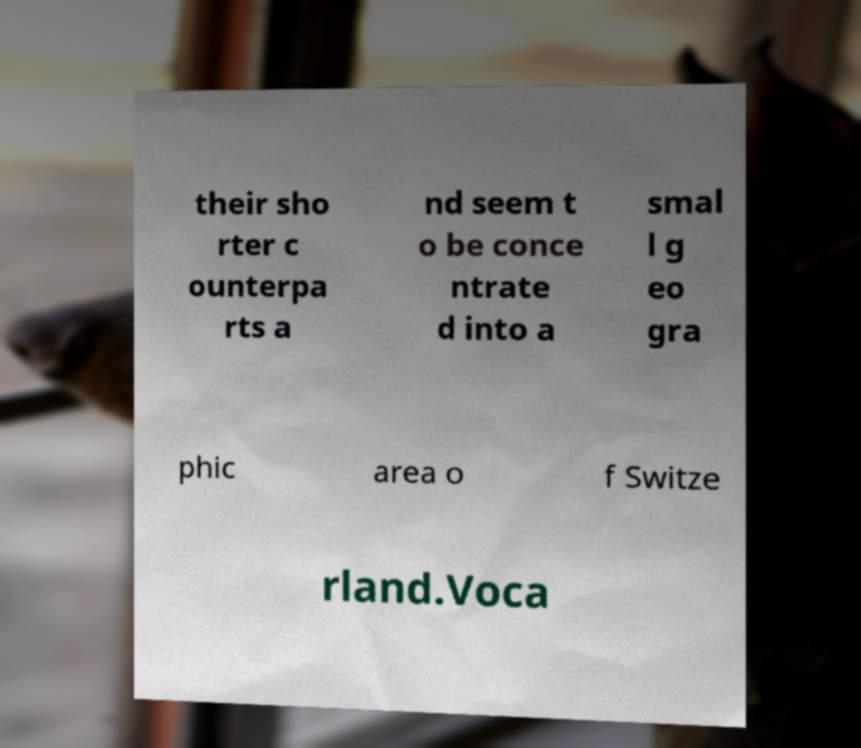For documentation purposes, I need the text within this image transcribed. Could you provide that? their sho rter c ounterpa rts a nd seem t o be conce ntrate d into a smal l g eo gra phic area o f Switze rland.Voca 